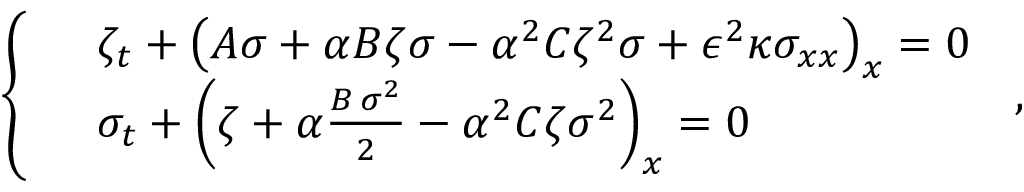<formula> <loc_0><loc_0><loc_500><loc_500>\left \{ \begin{array} { r l } & { \zeta _ { t } + \left ( A { \sigma } + \alpha B { \zeta } { \sigma } - \alpha ^ { 2 } C { \zeta } ^ { 2 } { \sigma } + \epsilon ^ { 2 } \kappa { \sigma } _ { x x } \right ) _ { x } = 0 } \\ & { \sigma _ { t } + \left ( { \zeta } + \alpha \frac { B \, { \sigma } ^ { 2 } } { 2 } - \alpha ^ { 2 } C { \zeta } { \sigma } ^ { 2 } \right ) _ { x } = 0 } \end{array} \, ,</formula> 